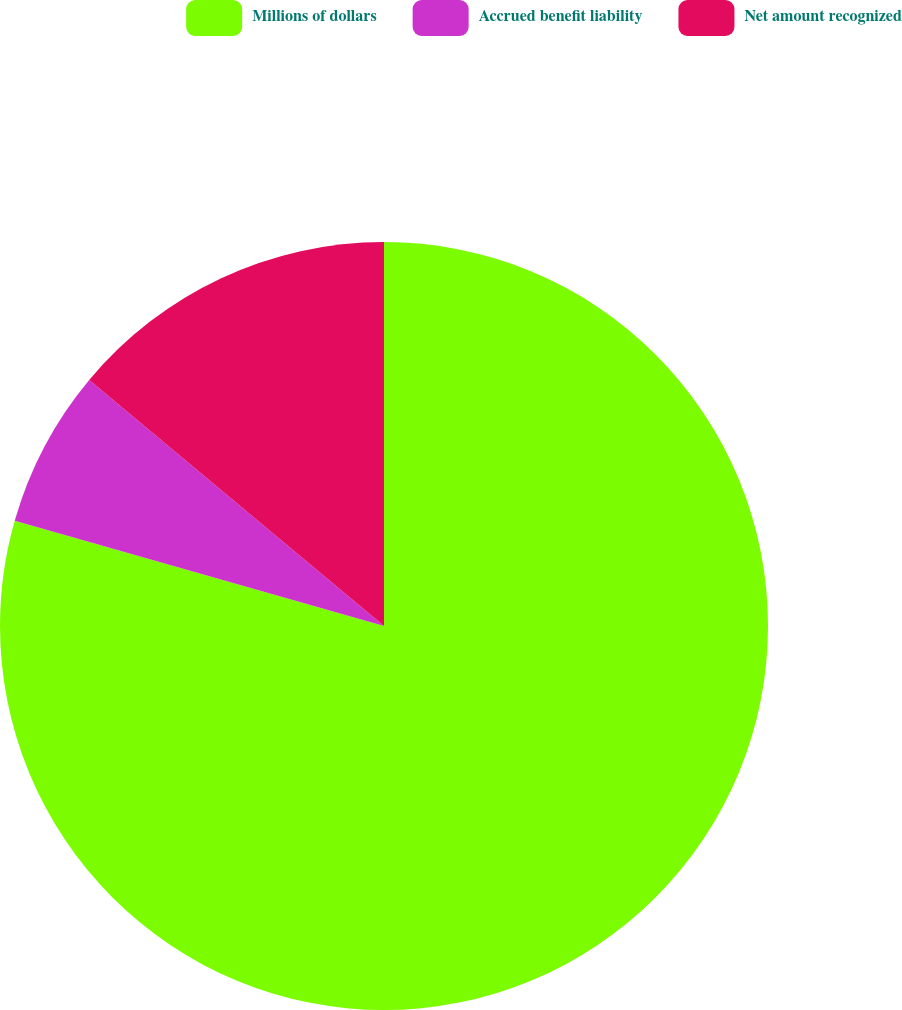Convert chart to OTSL. <chart><loc_0><loc_0><loc_500><loc_500><pie_chart><fcel>Millions of dollars<fcel>Accrued benefit liability<fcel>Net amount recognized<nl><fcel>79.42%<fcel>6.65%<fcel>13.93%<nl></chart> 